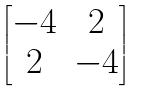Convert formula to latex. <formula><loc_0><loc_0><loc_500><loc_500>\begin{bmatrix} - 4 & 2 \\ 2 & - 4 \end{bmatrix}</formula> 